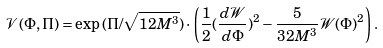Convert formula to latex. <formula><loc_0><loc_0><loc_500><loc_500>\mathcal { V } ( \Phi , \Pi ) = \exp { ( { \Pi } / { \sqrt { 1 2 M ^ { 3 } } } ) } \cdot \left ( \frac { 1 } { 2 } ( \frac { d \mathcal { W } } { d \Phi } ) ^ { 2 } - \frac { 5 } { 3 2 M ^ { 3 } } \mathcal { W } ( \Phi ) ^ { 2 } \right ) .</formula> 